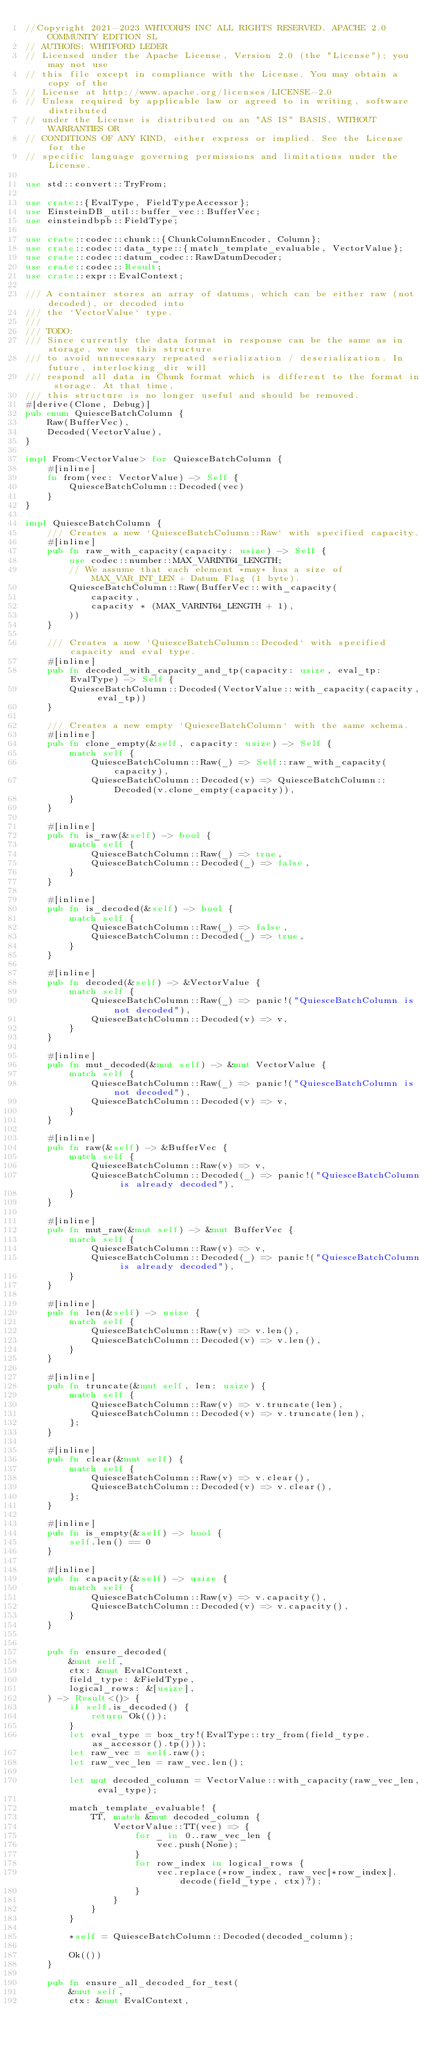<code> <loc_0><loc_0><loc_500><loc_500><_Rust_>//Copyright 2021-2023 WHTCORPS INC ALL RIGHTS RESERVED. APACHE 2.0 COMMUNITY EDITION SL
// AUTHORS: WHITFORD LEDER
// Licensed under the Apache License, Version 2.0 (the "License"); you may not use
// this file except in compliance with the License. You may obtain a copy of the
// License at http://www.apache.org/licenses/LICENSE-2.0
// Unless required by applicable law or agreed to in writing, software distributed
// under the License is distributed on an "AS IS" BASIS, WITHOUT WARRANTIES OR
// CONDITIONS OF ANY KIND, either express or implied. See the License for the
// specific language governing permissions and limitations under the License.

use std::convert::TryFrom;

use crate::{EvalType, FieldTypeAccessor};
use EinsteinDB_util::buffer_vec::BufferVec;
use einsteindbpb::FieldType;

use crate::codec::chunk::{ChunkColumnEncoder, Column};
use crate::codec::data_type::{match_template_evaluable, VectorValue};
use crate::codec::datum_codec::RawDatumDecoder;
use crate::codec::Result;
use crate::expr::EvalContext;

/// A container stores an array of datums, which can be either raw (not decoded), or decoded into
/// the `VectorValue` type.
///
/// TODO:
/// Since currently the data format in response can be the same as in storage, we use this structure
/// to avoid unnecessary repeated serialization / deserialization. In future, interlocking_dir will
/// respond all data in Chunk format which is different to the format in storage. At that time,
/// this structure is no longer useful and should be removed.
#[derive(Clone, Debug)]
pub enum QuiesceBatchColumn {
    Raw(BufferVec),
    Decoded(VectorValue),
}

impl From<VectorValue> for QuiesceBatchColumn {
    #[inline]
    fn from(vec: VectorValue) -> Self {
        QuiesceBatchColumn::Decoded(vec)
    }
}

impl QuiesceBatchColumn {
    /// Creates a new `QuiesceBatchColumn::Raw` with specified capacity.
    #[inline]
    pub fn raw_with_capacity(capacity: usize) -> Self {
        use codec::number::MAX_VARINT64_LENGTH;
        // We assume that each element *may* has a size of MAX_VAR_INT_LEN + Datum Flag (1 byte).
        QuiesceBatchColumn::Raw(BufferVec::with_capacity(
            capacity,
            capacity * (MAX_VARINT64_LENGTH + 1),
        ))
    }

    /// Creates a new `QuiesceBatchColumn::Decoded` with specified capacity and eval type.
    #[inline]
    pub fn decoded_with_capacity_and_tp(capacity: usize, eval_tp: EvalType) -> Self {
        QuiesceBatchColumn::Decoded(VectorValue::with_capacity(capacity, eval_tp))
    }

    /// Creates a new empty `QuiesceBatchColumn` with the same schema.
    #[inline]
    pub fn clone_empty(&self, capacity: usize) -> Self {
        match self {
            QuiesceBatchColumn::Raw(_) => Self::raw_with_capacity(capacity),
            QuiesceBatchColumn::Decoded(v) => QuiesceBatchColumn::Decoded(v.clone_empty(capacity)),
        }
    }

    #[inline]
    pub fn is_raw(&self) -> bool {
        match self {
            QuiesceBatchColumn::Raw(_) => true,
            QuiesceBatchColumn::Decoded(_) => false,
        }
    }

    #[inline]
    pub fn is_decoded(&self) -> bool {
        match self {
            QuiesceBatchColumn::Raw(_) => false,
            QuiesceBatchColumn::Decoded(_) => true,
        }
    }

    #[inline]
    pub fn decoded(&self) -> &VectorValue {
        match self {
            QuiesceBatchColumn::Raw(_) => panic!("QuiesceBatchColumn is not decoded"),
            QuiesceBatchColumn::Decoded(v) => v,
        }
    }

    #[inline]
    pub fn mut_decoded(&mut self) -> &mut VectorValue {
        match self {
            QuiesceBatchColumn::Raw(_) => panic!("QuiesceBatchColumn is not decoded"),
            QuiesceBatchColumn::Decoded(v) => v,
        }
    }

    #[inline]
    pub fn raw(&self) -> &BufferVec {
        match self {
            QuiesceBatchColumn::Raw(v) => v,
            QuiesceBatchColumn::Decoded(_) => panic!("QuiesceBatchColumn is already decoded"),
        }
    }

    #[inline]
    pub fn mut_raw(&mut self) -> &mut BufferVec {
        match self {
            QuiesceBatchColumn::Raw(v) => v,
            QuiesceBatchColumn::Decoded(_) => panic!("QuiesceBatchColumn is already decoded"),
        }
    }

    #[inline]
    pub fn len(&self) -> usize {
        match self {
            QuiesceBatchColumn::Raw(v) => v.len(),
            QuiesceBatchColumn::Decoded(v) => v.len(),
        }
    }

    #[inline]
    pub fn truncate(&mut self, len: usize) {
        match self {
            QuiesceBatchColumn::Raw(v) => v.truncate(len),
            QuiesceBatchColumn::Decoded(v) => v.truncate(len),
        };
    }

    #[inline]
    pub fn clear(&mut self) {
        match self {
            QuiesceBatchColumn::Raw(v) => v.clear(),
            QuiesceBatchColumn::Decoded(v) => v.clear(),
        };
    }

    #[inline]
    pub fn is_empty(&self) -> bool {
        self.len() == 0
    }

    #[inline]
    pub fn capacity(&self) -> usize {
        match self {
            QuiesceBatchColumn::Raw(v) => v.capacity(),
            QuiesceBatchColumn::Decoded(v) => v.capacity(),
        }
    }


    pub fn ensure_decoded(
        &mut self,
        ctx: &mut EvalContext,
        field_type: &FieldType,
        logical_rows: &[usize],
    ) -> Result<()> {
        if self.is_decoded() {
            return Ok(());
        }
        let eval_type = box_try!(EvalType::try_from(field_type.as_accessor().tp()));
        let raw_vec = self.raw();
        let raw_vec_len = raw_vec.len();

        let mut decoded_column = VectorValue::with_capacity(raw_vec_len, eval_type);

        match_template_evaluable! {
            TT, match &mut decoded_column {
                VectorValue::TT(vec) => {
                    for _ in 0..raw_vec_len {
                        vec.push(None);
                    }
                    for row_index in logical_rows {
                        vec.replace(*row_index, raw_vec[*row_index].decode(field_type, ctx)?);
                    }
                }
            }
        }

        *self = QuiesceBatchColumn::Decoded(decoded_column);

        Ok(())
    }

    pub fn ensure_all_decoded_for_test(
        &mut self,
        ctx: &mut EvalContext,</code> 